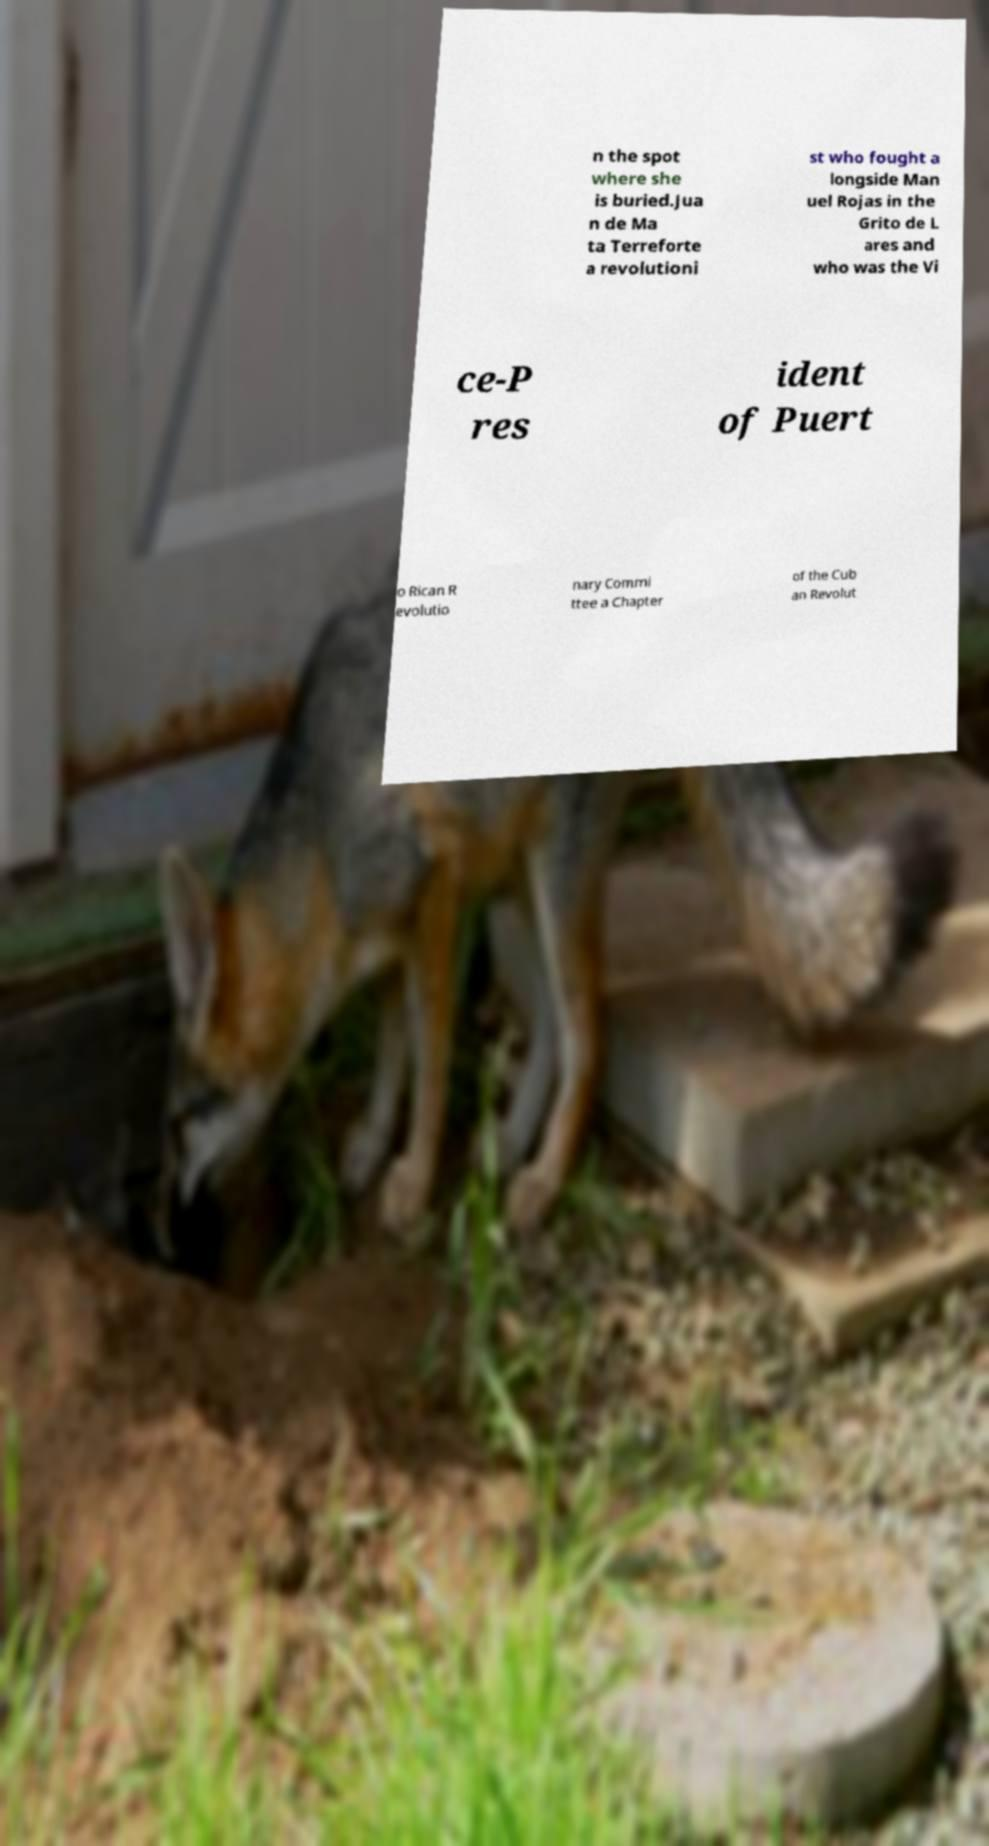Could you extract and type out the text from this image? n the spot where she is buried.Jua n de Ma ta Terreforte a revolutioni st who fought a longside Man uel Rojas in the Grito de L ares and who was the Vi ce-P res ident of Puert o Rican R evolutio nary Commi ttee a Chapter of the Cub an Revolut 